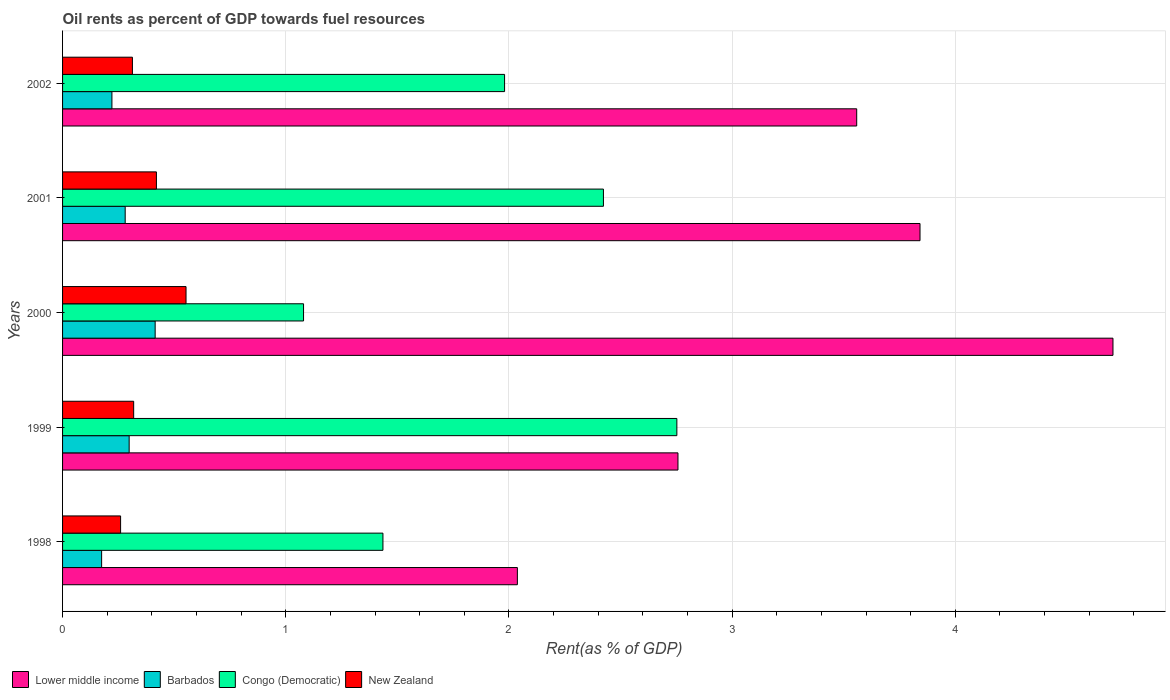How many different coloured bars are there?
Offer a very short reply. 4. How many bars are there on the 1st tick from the top?
Your response must be concise. 4. What is the oil rent in Lower middle income in 2000?
Keep it short and to the point. 4.71. Across all years, what is the maximum oil rent in Congo (Democratic)?
Keep it short and to the point. 2.75. Across all years, what is the minimum oil rent in Lower middle income?
Provide a succinct answer. 2.04. What is the total oil rent in Barbados in the graph?
Offer a terse response. 1.39. What is the difference between the oil rent in Barbados in 2000 and that in 2001?
Offer a very short reply. 0.13. What is the difference between the oil rent in Barbados in 2000 and the oil rent in Congo (Democratic) in 1998?
Provide a short and direct response. -1.02. What is the average oil rent in New Zealand per year?
Provide a short and direct response. 0.37. In the year 2000, what is the difference between the oil rent in Lower middle income and oil rent in Barbados?
Your answer should be compact. 4.29. What is the ratio of the oil rent in New Zealand in 1999 to that in 2000?
Give a very brief answer. 0.58. What is the difference between the highest and the second highest oil rent in Barbados?
Ensure brevity in your answer.  0.12. What is the difference between the highest and the lowest oil rent in Barbados?
Keep it short and to the point. 0.24. In how many years, is the oil rent in Barbados greater than the average oil rent in Barbados taken over all years?
Give a very brief answer. 3. Is it the case that in every year, the sum of the oil rent in Barbados and oil rent in Congo (Democratic) is greater than the sum of oil rent in Lower middle income and oil rent in New Zealand?
Keep it short and to the point. Yes. What does the 4th bar from the top in 1998 represents?
Provide a succinct answer. Lower middle income. What does the 1st bar from the bottom in 2001 represents?
Offer a terse response. Lower middle income. Are all the bars in the graph horizontal?
Your answer should be very brief. Yes. How many years are there in the graph?
Ensure brevity in your answer.  5. What is the difference between two consecutive major ticks on the X-axis?
Give a very brief answer. 1. Are the values on the major ticks of X-axis written in scientific E-notation?
Ensure brevity in your answer.  No. Does the graph contain any zero values?
Keep it short and to the point. No. How many legend labels are there?
Give a very brief answer. 4. How are the legend labels stacked?
Your answer should be compact. Horizontal. What is the title of the graph?
Your answer should be compact. Oil rents as percent of GDP towards fuel resources. Does "Nicaragua" appear as one of the legend labels in the graph?
Give a very brief answer. No. What is the label or title of the X-axis?
Your response must be concise. Rent(as % of GDP). What is the label or title of the Y-axis?
Your answer should be very brief. Years. What is the Rent(as % of GDP) of Lower middle income in 1998?
Ensure brevity in your answer.  2.04. What is the Rent(as % of GDP) of Barbados in 1998?
Keep it short and to the point. 0.18. What is the Rent(as % of GDP) of Congo (Democratic) in 1998?
Provide a succinct answer. 1.44. What is the Rent(as % of GDP) in New Zealand in 1998?
Make the answer very short. 0.26. What is the Rent(as % of GDP) in Lower middle income in 1999?
Give a very brief answer. 2.76. What is the Rent(as % of GDP) of Barbados in 1999?
Offer a very short reply. 0.3. What is the Rent(as % of GDP) in Congo (Democratic) in 1999?
Your answer should be very brief. 2.75. What is the Rent(as % of GDP) of New Zealand in 1999?
Provide a short and direct response. 0.32. What is the Rent(as % of GDP) in Lower middle income in 2000?
Provide a short and direct response. 4.71. What is the Rent(as % of GDP) in Barbados in 2000?
Offer a very short reply. 0.41. What is the Rent(as % of GDP) in Congo (Democratic) in 2000?
Ensure brevity in your answer.  1.08. What is the Rent(as % of GDP) of New Zealand in 2000?
Offer a terse response. 0.55. What is the Rent(as % of GDP) in Lower middle income in 2001?
Your answer should be compact. 3.84. What is the Rent(as % of GDP) of Barbados in 2001?
Ensure brevity in your answer.  0.28. What is the Rent(as % of GDP) in Congo (Democratic) in 2001?
Ensure brevity in your answer.  2.42. What is the Rent(as % of GDP) of New Zealand in 2001?
Offer a terse response. 0.42. What is the Rent(as % of GDP) of Lower middle income in 2002?
Your response must be concise. 3.56. What is the Rent(as % of GDP) in Barbados in 2002?
Your response must be concise. 0.22. What is the Rent(as % of GDP) of Congo (Democratic) in 2002?
Ensure brevity in your answer.  1.98. What is the Rent(as % of GDP) in New Zealand in 2002?
Offer a terse response. 0.31. Across all years, what is the maximum Rent(as % of GDP) of Lower middle income?
Ensure brevity in your answer.  4.71. Across all years, what is the maximum Rent(as % of GDP) in Barbados?
Provide a succinct answer. 0.41. Across all years, what is the maximum Rent(as % of GDP) in Congo (Democratic)?
Keep it short and to the point. 2.75. Across all years, what is the maximum Rent(as % of GDP) in New Zealand?
Give a very brief answer. 0.55. Across all years, what is the minimum Rent(as % of GDP) in Lower middle income?
Ensure brevity in your answer.  2.04. Across all years, what is the minimum Rent(as % of GDP) of Barbados?
Your answer should be compact. 0.18. Across all years, what is the minimum Rent(as % of GDP) in Congo (Democratic)?
Offer a very short reply. 1.08. Across all years, what is the minimum Rent(as % of GDP) in New Zealand?
Offer a terse response. 0.26. What is the total Rent(as % of GDP) of Lower middle income in the graph?
Ensure brevity in your answer.  16.9. What is the total Rent(as % of GDP) in Barbados in the graph?
Ensure brevity in your answer.  1.39. What is the total Rent(as % of GDP) of Congo (Democratic) in the graph?
Give a very brief answer. 9.67. What is the total Rent(as % of GDP) of New Zealand in the graph?
Offer a very short reply. 1.87. What is the difference between the Rent(as % of GDP) in Lower middle income in 1998 and that in 1999?
Ensure brevity in your answer.  -0.72. What is the difference between the Rent(as % of GDP) in Barbados in 1998 and that in 1999?
Your response must be concise. -0.12. What is the difference between the Rent(as % of GDP) of Congo (Democratic) in 1998 and that in 1999?
Offer a very short reply. -1.32. What is the difference between the Rent(as % of GDP) in New Zealand in 1998 and that in 1999?
Your answer should be very brief. -0.06. What is the difference between the Rent(as % of GDP) of Lower middle income in 1998 and that in 2000?
Your response must be concise. -2.67. What is the difference between the Rent(as % of GDP) of Barbados in 1998 and that in 2000?
Provide a short and direct response. -0.24. What is the difference between the Rent(as % of GDP) in Congo (Democratic) in 1998 and that in 2000?
Keep it short and to the point. 0.36. What is the difference between the Rent(as % of GDP) in New Zealand in 1998 and that in 2000?
Ensure brevity in your answer.  -0.29. What is the difference between the Rent(as % of GDP) of Lower middle income in 1998 and that in 2001?
Ensure brevity in your answer.  -1.8. What is the difference between the Rent(as % of GDP) in Barbados in 1998 and that in 2001?
Give a very brief answer. -0.11. What is the difference between the Rent(as % of GDP) of Congo (Democratic) in 1998 and that in 2001?
Your answer should be very brief. -0.99. What is the difference between the Rent(as % of GDP) of New Zealand in 1998 and that in 2001?
Offer a very short reply. -0.16. What is the difference between the Rent(as % of GDP) in Lower middle income in 1998 and that in 2002?
Ensure brevity in your answer.  -1.52. What is the difference between the Rent(as % of GDP) in Barbados in 1998 and that in 2002?
Your response must be concise. -0.05. What is the difference between the Rent(as % of GDP) in Congo (Democratic) in 1998 and that in 2002?
Give a very brief answer. -0.55. What is the difference between the Rent(as % of GDP) of New Zealand in 1998 and that in 2002?
Ensure brevity in your answer.  -0.05. What is the difference between the Rent(as % of GDP) of Lower middle income in 1999 and that in 2000?
Ensure brevity in your answer.  -1.95. What is the difference between the Rent(as % of GDP) of Barbados in 1999 and that in 2000?
Your answer should be very brief. -0.12. What is the difference between the Rent(as % of GDP) of Congo (Democratic) in 1999 and that in 2000?
Keep it short and to the point. 1.67. What is the difference between the Rent(as % of GDP) of New Zealand in 1999 and that in 2000?
Your answer should be compact. -0.23. What is the difference between the Rent(as % of GDP) of Lower middle income in 1999 and that in 2001?
Offer a terse response. -1.08. What is the difference between the Rent(as % of GDP) in Barbados in 1999 and that in 2001?
Keep it short and to the point. 0.02. What is the difference between the Rent(as % of GDP) of Congo (Democratic) in 1999 and that in 2001?
Provide a short and direct response. 0.33. What is the difference between the Rent(as % of GDP) in New Zealand in 1999 and that in 2001?
Offer a terse response. -0.1. What is the difference between the Rent(as % of GDP) in Lower middle income in 1999 and that in 2002?
Your answer should be very brief. -0.8. What is the difference between the Rent(as % of GDP) of Barbados in 1999 and that in 2002?
Offer a very short reply. 0.08. What is the difference between the Rent(as % of GDP) in Congo (Democratic) in 1999 and that in 2002?
Your answer should be compact. 0.77. What is the difference between the Rent(as % of GDP) of New Zealand in 1999 and that in 2002?
Make the answer very short. 0.01. What is the difference between the Rent(as % of GDP) in Lower middle income in 2000 and that in 2001?
Your answer should be compact. 0.86. What is the difference between the Rent(as % of GDP) of Barbados in 2000 and that in 2001?
Ensure brevity in your answer.  0.13. What is the difference between the Rent(as % of GDP) of Congo (Democratic) in 2000 and that in 2001?
Ensure brevity in your answer.  -1.34. What is the difference between the Rent(as % of GDP) in New Zealand in 2000 and that in 2001?
Offer a very short reply. 0.13. What is the difference between the Rent(as % of GDP) of Lower middle income in 2000 and that in 2002?
Offer a very short reply. 1.15. What is the difference between the Rent(as % of GDP) in Barbados in 2000 and that in 2002?
Make the answer very short. 0.19. What is the difference between the Rent(as % of GDP) of Congo (Democratic) in 2000 and that in 2002?
Ensure brevity in your answer.  -0.9. What is the difference between the Rent(as % of GDP) of New Zealand in 2000 and that in 2002?
Make the answer very short. 0.24. What is the difference between the Rent(as % of GDP) in Lower middle income in 2001 and that in 2002?
Provide a succinct answer. 0.28. What is the difference between the Rent(as % of GDP) of Barbados in 2001 and that in 2002?
Ensure brevity in your answer.  0.06. What is the difference between the Rent(as % of GDP) in Congo (Democratic) in 2001 and that in 2002?
Make the answer very short. 0.44. What is the difference between the Rent(as % of GDP) of New Zealand in 2001 and that in 2002?
Provide a succinct answer. 0.11. What is the difference between the Rent(as % of GDP) of Lower middle income in 1998 and the Rent(as % of GDP) of Barbados in 1999?
Offer a terse response. 1.74. What is the difference between the Rent(as % of GDP) in Lower middle income in 1998 and the Rent(as % of GDP) in Congo (Democratic) in 1999?
Give a very brief answer. -0.71. What is the difference between the Rent(as % of GDP) of Lower middle income in 1998 and the Rent(as % of GDP) of New Zealand in 1999?
Offer a very short reply. 1.72. What is the difference between the Rent(as % of GDP) of Barbados in 1998 and the Rent(as % of GDP) of Congo (Democratic) in 1999?
Offer a very short reply. -2.58. What is the difference between the Rent(as % of GDP) in Barbados in 1998 and the Rent(as % of GDP) in New Zealand in 1999?
Your answer should be compact. -0.14. What is the difference between the Rent(as % of GDP) in Congo (Democratic) in 1998 and the Rent(as % of GDP) in New Zealand in 1999?
Your response must be concise. 1.12. What is the difference between the Rent(as % of GDP) of Lower middle income in 1998 and the Rent(as % of GDP) of Barbados in 2000?
Your answer should be very brief. 1.62. What is the difference between the Rent(as % of GDP) in Lower middle income in 1998 and the Rent(as % of GDP) in Congo (Democratic) in 2000?
Provide a short and direct response. 0.96. What is the difference between the Rent(as % of GDP) of Lower middle income in 1998 and the Rent(as % of GDP) of New Zealand in 2000?
Give a very brief answer. 1.48. What is the difference between the Rent(as % of GDP) of Barbados in 1998 and the Rent(as % of GDP) of Congo (Democratic) in 2000?
Keep it short and to the point. -0.9. What is the difference between the Rent(as % of GDP) in Barbados in 1998 and the Rent(as % of GDP) in New Zealand in 2000?
Make the answer very short. -0.38. What is the difference between the Rent(as % of GDP) of Congo (Democratic) in 1998 and the Rent(as % of GDP) of New Zealand in 2000?
Your response must be concise. 0.88. What is the difference between the Rent(as % of GDP) in Lower middle income in 1998 and the Rent(as % of GDP) in Barbados in 2001?
Keep it short and to the point. 1.76. What is the difference between the Rent(as % of GDP) in Lower middle income in 1998 and the Rent(as % of GDP) in Congo (Democratic) in 2001?
Your response must be concise. -0.39. What is the difference between the Rent(as % of GDP) in Lower middle income in 1998 and the Rent(as % of GDP) in New Zealand in 2001?
Provide a succinct answer. 1.62. What is the difference between the Rent(as % of GDP) in Barbados in 1998 and the Rent(as % of GDP) in Congo (Democratic) in 2001?
Your answer should be compact. -2.25. What is the difference between the Rent(as % of GDP) of Barbados in 1998 and the Rent(as % of GDP) of New Zealand in 2001?
Offer a terse response. -0.25. What is the difference between the Rent(as % of GDP) of Lower middle income in 1998 and the Rent(as % of GDP) of Barbados in 2002?
Your answer should be very brief. 1.82. What is the difference between the Rent(as % of GDP) in Lower middle income in 1998 and the Rent(as % of GDP) in Congo (Democratic) in 2002?
Your answer should be very brief. 0.06. What is the difference between the Rent(as % of GDP) in Lower middle income in 1998 and the Rent(as % of GDP) in New Zealand in 2002?
Provide a succinct answer. 1.72. What is the difference between the Rent(as % of GDP) in Barbados in 1998 and the Rent(as % of GDP) in Congo (Democratic) in 2002?
Provide a short and direct response. -1.81. What is the difference between the Rent(as % of GDP) of Barbados in 1998 and the Rent(as % of GDP) of New Zealand in 2002?
Offer a very short reply. -0.14. What is the difference between the Rent(as % of GDP) of Congo (Democratic) in 1998 and the Rent(as % of GDP) of New Zealand in 2002?
Make the answer very short. 1.12. What is the difference between the Rent(as % of GDP) in Lower middle income in 1999 and the Rent(as % of GDP) in Barbados in 2000?
Give a very brief answer. 2.34. What is the difference between the Rent(as % of GDP) of Lower middle income in 1999 and the Rent(as % of GDP) of Congo (Democratic) in 2000?
Make the answer very short. 1.68. What is the difference between the Rent(as % of GDP) in Lower middle income in 1999 and the Rent(as % of GDP) in New Zealand in 2000?
Your response must be concise. 2.2. What is the difference between the Rent(as % of GDP) of Barbados in 1999 and the Rent(as % of GDP) of Congo (Democratic) in 2000?
Provide a succinct answer. -0.78. What is the difference between the Rent(as % of GDP) in Barbados in 1999 and the Rent(as % of GDP) in New Zealand in 2000?
Give a very brief answer. -0.25. What is the difference between the Rent(as % of GDP) of Congo (Democratic) in 1999 and the Rent(as % of GDP) of New Zealand in 2000?
Give a very brief answer. 2.2. What is the difference between the Rent(as % of GDP) in Lower middle income in 1999 and the Rent(as % of GDP) in Barbados in 2001?
Your answer should be very brief. 2.48. What is the difference between the Rent(as % of GDP) of Lower middle income in 1999 and the Rent(as % of GDP) of Congo (Democratic) in 2001?
Provide a succinct answer. 0.33. What is the difference between the Rent(as % of GDP) of Lower middle income in 1999 and the Rent(as % of GDP) of New Zealand in 2001?
Offer a terse response. 2.34. What is the difference between the Rent(as % of GDP) in Barbados in 1999 and the Rent(as % of GDP) in Congo (Democratic) in 2001?
Offer a terse response. -2.13. What is the difference between the Rent(as % of GDP) in Barbados in 1999 and the Rent(as % of GDP) in New Zealand in 2001?
Offer a very short reply. -0.12. What is the difference between the Rent(as % of GDP) in Congo (Democratic) in 1999 and the Rent(as % of GDP) in New Zealand in 2001?
Give a very brief answer. 2.33. What is the difference between the Rent(as % of GDP) in Lower middle income in 1999 and the Rent(as % of GDP) in Barbados in 2002?
Give a very brief answer. 2.54. What is the difference between the Rent(as % of GDP) of Lower middle income in 1999 and the Rent(as % of GDP) of Congo (Democratic) in 2002?
Your response must be concise. 0.78. What is the difference between the Rent(as % of GDP) in Lower middle income in 1999 and the Rent(as % of GDP) in New Zealand in 2002?
Give a very brief answer. 2.44. What is the difference between the Rent(as % of GDP) in Barbados in 1999 and the Rent(as % of GDP) in Congo (Democratic) in 2002?
Your answer should be compact. -1.68. What is the difference between the Rent(as % of GDP) of Barbados in 1999 and the Rent(as % of GDP) of New Zealand in 2002?
Provide a succinct answer. -0.01. What is the difference between the Rent(as % of GDP) in Congo (Democratic) in 1999 and the Rent(as % of GDP) in New Zealand in 2002?
Your answer should be very brief. 2.44. What is the difference between the Rent(as % of GDP) of Lower middle income in 2000 and the Rent(as % of GDP) of Barbados in 2001?
Ensure brevity in your answer.  4.43. What is the difference between the Rent(as % of GDP) in Lower middle income in 2000 and the Rent(as % of GDP) in Congo (Democratic) in 2001?
Offer a very short reply. 2.28. What is the difference between the Rent(as % of GDP) in Lower middle income in 2000 and the Rent(as % of GDP) in New Zealand in 2001?
Make the answer very short. 4.29. What is the difference between the Rent(as % of GDP) of Barbados in 2000 and the Rent(as % of GDP) of Congo (Democratic) in 2001?
Offer a very short reply. -2.01. What is the difference between the Rent(as % of GDP) of Barbados in 2000 and the Rent(as % of GDP) of New Zealand in 2001?
Provide a short and direct response. -0.01. What is the difference between the Rent(as % of GDP) in Congo (Democratic) in 2000 and the Rent(as % of GDP) in New Zealand in 2001?
Offer a terse response. 0.66. What is the difference between the Rent(as % of GDP) in Lower middle income in 2000 and the Rent(as % of GDP) in Barbados in 2002?
Make the answer very short. 4.49. What is the difference between the Rent(as % of GDP) of Lower middle income in 2000 and the Rent(as % of GDP) of Congo (Democratic) in 2002?
Offer a very short reply. 2.73. What is the difference between the Rent(as % of GDP) in Lower middle income in 2000 and the Rent(as % of GDP) in New Zealand in 2002?
Keep it short and to the point. 4.39. What is the difference between the Rent(as % of GDP) of Barbados in 2000 and the Rent(as % of GDP) of Congo (Democratic) in 2002?
Your answer should be compact. -1.57. What is the difference between the Rent(as % of GDP) in Barbados in 2000 and the Rent(as % of GDP) in New Zealand in 2002?
Offer a very short reply. 0.1. What is the difference between the Rent(as % of GDP) of Congo (Democratic) in 2000 and the Rent(as % of GDP) of New Zealand in 2002?
Offer a very short reply. 0.77. What is the difference between the Rent(as % of GDP) of Lower middle income in 2001 and the Rent(as % of GDP) of Barbados in 2002?
Your answer should be very brief. 3.62. What is the difference between the Rent(as % of GDP) in Lower middle income in 2001 and the Rent(as % of GDP) in Congo (Democratic) in 2002?
Give a very brief answer. 1.86. What is the difference between the Rent(as % of GDP) in Lower middle income in 2001 and the Rent(as % of GDP) in New Zealand in 2002?
Your answer should be compact. 3.53. What is the difference between the Rent(as % of GDP) of Barbados in 2001 and the Rent(as % of GDP) of Congo (Democratic) in 2002?
Offer a terse response. -1.7. What is the difference between the Rent(as % of GDP) in Barbados in 2001 and the Rent(as % of GDP) in New Zealand in 2002?
Offer a very short reply. -0.03. What is the difference between the Rent(as % of GDP) of Congo (Democratic) in 2001 and the Rent(as % of GDP) of New Zealand in 2002?
Provide a succinct answer. 2.11. What is the average Rent(as % of GDP) of Lower middle income per year?
Provide a short and direct response. 3.38. What is the average Rent(as % of GDP) in Barbados per year?
Ensure brevity in your answer.  0.28. What is the average Rent(as % of GDP) in Congo (Democratic) per year?
Keep it short and to the point. 1.93. What is the average Rent(as % of GDP) in New Zealand per year?
Ensure brevity in your answer.  0.37. In the year 1998, what is the difference between the Rent(as % of GDP) of Lower middle income and Rent(as % of GDP) of Barbados?
Provide a short and direct response. 1.86. In the year 1998, what is the difference between the Rent(as % of GDP) in Lower middle income and Rent(as % of GDP) in Congo (Democratic)?
Make the answer very short. 0.6. In the year 1998, what is the difference between the Rent(as % of GDP) of Lower middle income and Rent(as % of GDP) of New Zealand?
Offer a very short reply. 1.78. In the year 1998, what is the difference between the Rent(as % of GDP) of Barbados and Rent(as % of GDP) of Congo (Democratic)?
Provide a short and direct response. -1.26. In the year 1998, what is the difference between the Rent(as % of GDP) in Barbados and Rent(as % of GDP) in New Zealand?
Your response must be concise. -0.09. In the year 1998, what is the difference between the Rent(as % of GDP) of Congo (Democratic) and Rent(as % of GDP) of New Zealand?
Provide a short and direct response. 1.18. In the year 1999, what is the difference between the Rent(as % of GDP) in Lower middle income and Rent(as % of GDP) in Barbados?
Your answer should be compact. 2.46. In the year 1999, what is the difference between the Rent(as % of GDP) in Lower middle income and Rent(as % of GDP) in Congo (Democratic)?
Your response must be concise. 0.01. In the year 1999, what is the difference between the Rent(as % of GDP) in Lower middle income and Rent(as % of GDP) in New Zealand?
Your answer should be compact. 2.44. In the year 1999, what is the difference between the Rent(as % of GDP) of Barbados and Rent(as % of GDP) of Congo (Democratic)?
Give a very brief answer. -2.45. In the year 1999, what is the difference between the Rent(as % of GDP) of Barbados and Rent(as % of GDP) of New Zealand?
Give a very brief answer. -0.02. In the year 1999, what is the difference between the Rent(as % of GDP) of Congo (Democratic) and Rent(as % of GDP) of New Zealand?
Make the answer very short. 2.43. In the year 2000, what is the difference between the Rent(as % of GDP) in Lower middle income and Rent(as % of GDP) in Barbados?
Your response must be concise. 4.29. In the year 2000, what is the difference between the Rent(as % of GDP) of Lower middle income and Rent(as % of GDP) of Congo (Democratic)?
Offer a terse response. 3.63. In the year 2000, what is the difference between the Rent(as % of GDP) of Lower middle income and Rent(as % of GDP) of New Zealand?
Your answer should be very brief. 4.15. In the year 2000, what is the difference between the Rent(as % of GDP) of Barbados and Rent(as % of GDP) of Congo (Democratic)?
Your answer should be very brief. -0.66. In the year 2000, what is the difference between the Rent(as % of GDP) in Barbados and Rent(as % of GDP) in New Zealand?
Provide a short and direct response. -0.14. In the year 2000, what is the difference between the Rent(as % of GDP) of Congo (Democratic) and Rent(as % of GDP) of New Zealand?
Make the answer very short. 0.53. In the year 2001, what is the difference between the Rent(as % of GDP) in Lower middle income and Rent(as % of GDP) in Barbados?
Your answer should be very brief. 3.56. In the year 2001, what is the difference between the Rent(as % of GDP) in Lower middle income and Rent(as % of GDP) in Congo (Democratic)?
Offer a terse response. 1.42. In the year 2001, what is the difference between the Rent(as % of GDP) in Lower middle income and Rent(as % of GDP) in New Zealand?
Offer a terse response. 3.42. In the year 2001, what is the difference between the Rent(as % of GDP) of Barbados and Rent(as % of GDP) of Congo (Democratic)?
Your answer should be compact. -2.14. In the year 2001, what is the difference between the Rent(as % of GDP) in Barbados and Rent(as % of GDP) in New Zealand?
Make the answer very short. -0.14. In the year 2001, what is the difference between the Rent(as % of GDP) in Congo (Democratic) and Rent(as % of GDP) in New Zealand?
Your response must be concise. 2. In the year 2002, what is the difference between the Rent(as % of GDP) of Lower middle income and Rent(as % of GDP) of Barbados?
Offer a very short reply. 3.34. In the year 2002, what is the difference between the Rent(as % of GDP) of Lower middle income and Rent(as % of GDP) of Congo (Democratic)?
Give a very brief answer. 1.58. In the year 2002, what is the difference between the Rent(as % of GDP) of Lower middle income and Rent(as % of GDP) of New Zealand?
Give a very brief answer. 3.25. In the year 2002, what is the difference between the Rent(as % of GDP) of Barbados and Rent(as % of GDP) of Congo (Democratic)?
Ensure brevity in your answer.  -1.76. In the year 2002, what is the difference between the Rent(as % of GDP) of Barbados and Rent(as % of GDP) of New Zealand?
Keep it short and to the point. -0.09. In the year 2002, what is the difference between the Rent(as % of GDP) in Congo (Democratic) and Rent(as % of GDP) in New Zealand?
Offer a terse response. 1.67. What is the ratio of the Rent(as % of GDP) in Lower middle income in 1998 to that in 1999?
Provide a succinct answer. 0.74. What is the ratio of the Rent(as % of GDP) of Barbados in 1998 to that in 1999?
Give a very brief answer. 0.59. What is the ratio of the Rent(as % of GDP) of Congo (Democratic) in 1998 to that in 1999?
Your response must be concise. 0.52. What is the ratio of the Rent(as % of GDP) in New Zealand in 1998 to that in 1999?
Offer a terse response. 0.82. What is the ratio of the Rent(as % of GDP) in Lower middle income in 1998 to that in 2000?
Your answer should be very brief. 0.43. What is the ratio of the Rent(as % of GDP) of Barbados in 1998 to that in 2000?
Your response must be concise. 0.42. What is the ratio of the Rent(as % of GDP) in Congo (Democratic) in 1998 to that in 2000?
Your answer should be very brief. 1.33. What is the ratio of the Rent(as % of GDP) of New Zealand in 1998 to that in 2000?
Ensure brevity in your answer.  0.47. What is the ratio of the Rent(as % of GDP) of Lower middle income in 1998 to that in 2001?
Provide a succinct answer. 0.53. What is the ratio of the Rent(as % of GDP) of Barbados in 1998 to that in 2001?
Give a very brief answer. 0.62. What is the ratio of the Rent(as % of GDP) of Congo (Democratic) in 1998 to that in 2001?
Give a very brief answer. 0.59. What is the ratio of the Rent(as % of GDP) in New Zealand in 1998 to that in 2001?
Provide a succinct answer. 0.62. What is the ratio of the Rent(as % of GDP) in Lower middle income in 1998 to that in 2002?
Your answer should be compact. 0.57. What is the ratio of the Rent(as % of GDP) in Barbados in 1998 to that in 2002?
Your response must be concise. 0.79. What is the ratio of the Rent(as % of GDP) in Congo (Democratic) in 1998 to that in 2002?
Your answer should be compact. 0.72. What is the ratio of the Rent(as % of GDP) in New Zealand in 1998 to that in 2002?
Give a very brief answer. 0.83. What is the ratio of the Rent(as % of GDP) of Lower middle income in 1999 to that in 2000?
Give a very brief answer. 0.59. What is the ratio of the Rent(as % of GDP) in Barbados in 1999 to that in 2000?
Make the answer very short. 0.72. What is the ratio of the Rent(as % of GDP) of Congo (Democratic) in 1999 to that in 2000?
Ensure brevity in your answer.  2.55. What is the ratio of the Rent(as % of GDP) of New Zealand in 1999 to that in 2000?
Offer a terse response. 0.58. What is the ratio of the Rent(as % of GDP) in Lower middle income in 1999 to that in 2001?
Make the answer very short. 0.72. What is the ratio of the Rent(as % of GDP) of Barbados in 1999 to that in 2001?
Your answer should be compact. 1.06. What is the ratio of the Rent(as % of GDP) in Congo (Democratic) in 1999 to that in 2001?
Keep it short and to the point. 1.14. What is the ratio of the Rent(as % of GDP) in New Zealand in 1999 to that in 2001?
Offer a very short reply. 0.76. What is the ratio of the Rent(as % of GDP) of Lower middle income in 1999 to that in 2002?
Your answer should be very brief. 0.77. What is the ratio of the Rent(as % of GDP) in Barbados in 1999 to that in 2002?
Your answer should be compact. 1.35. What is the ratio of the Rent(as % of GDP) of Congo (Democratic) in 1999 to that in 2002?
Your answer should be compact. 1.39. What is the ratio of the Rent(as % of GDP) of New Zealand in 1999 to that in 2002?
Offer a terse response. 1.02. What is the ratio of the Rent(as % of GDP) of Lower middle income in 2000 to that in 2001?
Offer a very short reply. 1.23. What is the ratio of the Rent(as % of GDP) in Barbados in 2000 to that in 2001?
Give a very brief answer. 1.48. What is the ratio of the Rent(as % of GDP) of Congo (Democratic) in 2000 to that in 2001?
Provide a short and direct response. 0.45. What is the ratio of the Rent(as % of GDP) in New Zealand in 2000 to that in 2001?
Provide a short and direct response. 1.32. What is the ratio of the Rent(as % of GDP) of Lower middle income in 2000 to that in 2002?
Offer a terse response. 1.32. What is the ratio of the Rent(as % of GDP) of Barbados in 2000 to that in 2002?
Offer a very short reply. 1.88. What is the ratio of the Rent(as % of GDP) in Congo (Democratic) in 2000 to that in 2002?
Provide a succinct answer. 0.55. What is the ratio of the Rent(as % of GDP) of New Zealand in 2000 to that in 2002?
Provide a short and direct response. 1.77. What is the ratio of the Rent(as % of GDP) of Lower middle income in 2001 to that in 2002?
Your answer should be very brief. 1.08. What is the ratio of the Rent(as % of GDP) in Barbados in 2001 to that in 2002?
Your answer should be very brief. 1.27. What is the ratio of the Rent(as % of GDP) in Congo (Democratic) in 2001 to that in 2002?
Your answer should be very brief. 1.22. What is the ratio of the Rent(as % of GDP) in New Zealand in 2001 to that in 2002?
Your answer should be compact. 1.34. What is the difference between the highest and the second highest Rent(as % of GDP) in Lower middle income?
Give a very brief answer. 0.86. What is the difference between the highest and the second highest Rent(as % of GDP) in Barbados?
Offer a very short reply. 0.12. What is the difference between the highest and the second highest Rent(as % of GDP) of Congo (Democratic)?
Give a very brief answer. 0.33. What is the difference between the highest and the second highest Rent(as % of GDP) in New Zealand?
Your response must be concise. 0.13. What is the difference between the highest and the lowest Rent(as % of GDP) of Lower middle income?
Provide a succinct answer. 2.67. What is the difference between the highest and the lowest Rent(as % of GDP) of Barbados?
Make the answer very short. 0.24. What is the difference between the highest and the lowest Rent(as % of GDP) in Congo (Democratic)?
Provide a short and direct response. 1.67. What is the difference between the highest and the lowest Rent(as % of GDP) in New Zealand?
Make the answer very short. 0.29. 